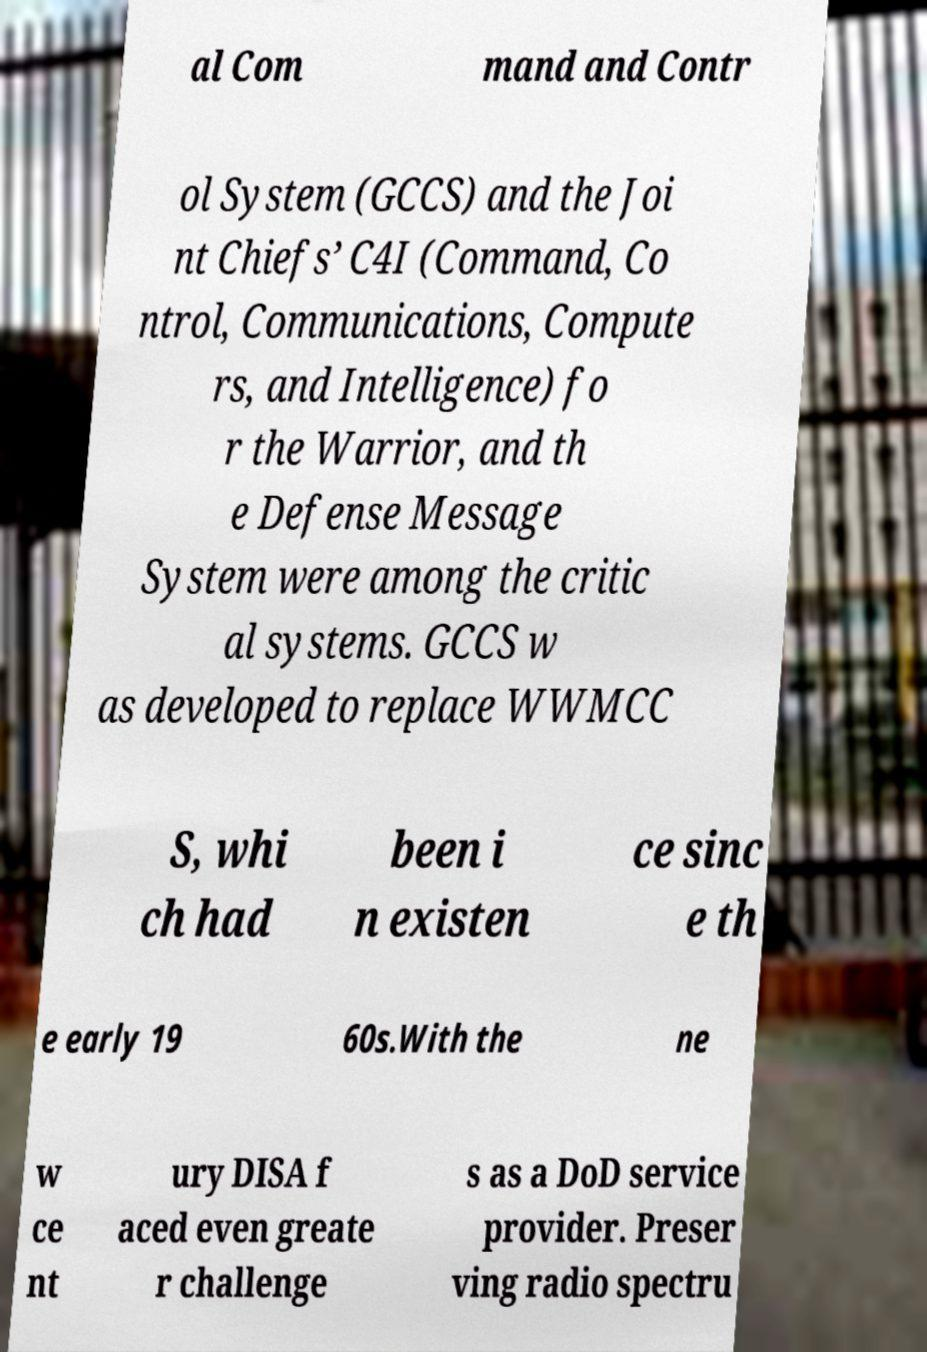Could you assist in decoding the text presented in this image and type it out clearly? al Com mand and Contr ol System (GCCS) and the Joi nt Chiefs’ C4I (Command, Co ntrol, Communications, Compute rs, and Intelligence) fo r the Warrior, and th e Defense Message System were among the critic al systems. GCCS w as developed to replace WWMCC S, whi ch had been i n existen ce sinc e th e early 19 60s.With the ne w ce nt ury DISA f aced even greate r challenge s as a DoD service provider. Preser ving radio spectru 